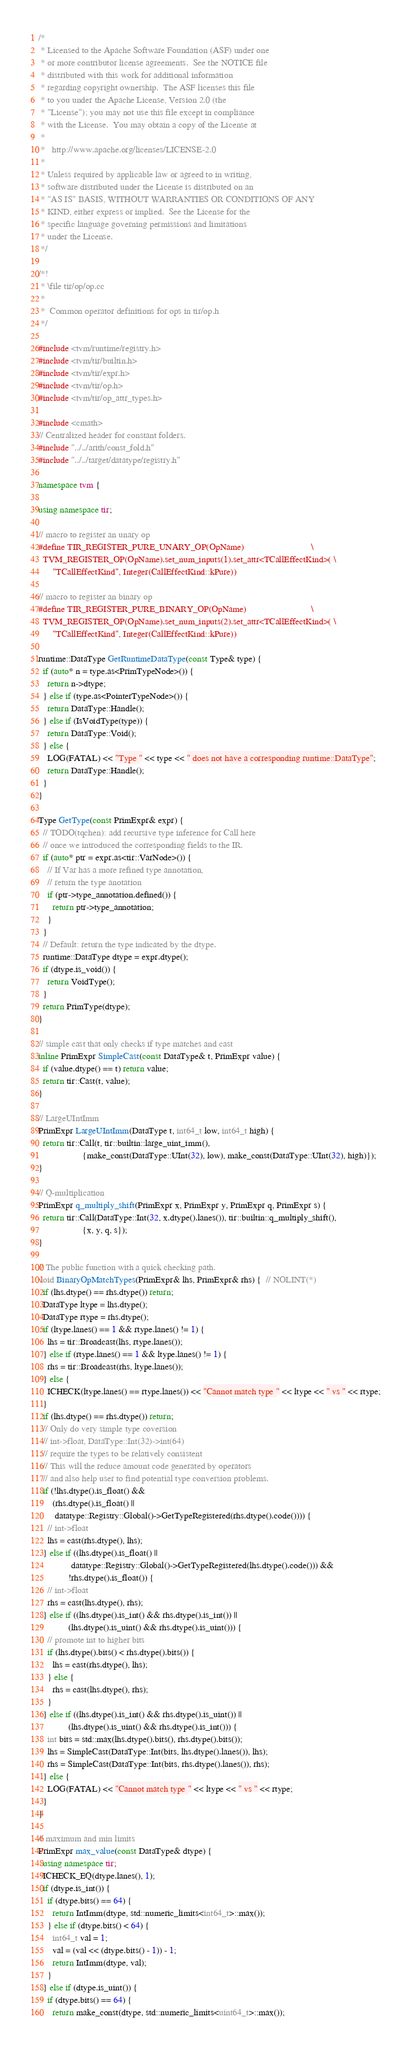Convert code to text. <code><loc_0><loc_0><loc_500><loc_500><_C++_>/*
 * Licensed to the Apache Software Foundation (ASF) under one
 * or more contributor license agreements.  See the NOTICE file
 * distributed with this work for additional information
 * regarding copyright ownership.  The ASF licenses this file
 * to you under the Apache License, Version 2.0 (the
 * "License"); you may not use this file except in compliance
 * with the License.  You may obtain a copy of the License at
 *
 *   http://www.apache.org/licenses/LICENSE-2.0
 *
 * Unless required by applicable law or agreed to in writing,
 * software distributed under the License is distributed on an
 * "AS IS" BASIS, WITHOUT WARRANTIES OR CONDITIONS OF ANY
 * KIND, either express or implied.  See the License for the
 * specific language governing permissions and limitations
 * under the License.
 */

/*!
 * \file tir/op/op.cc
 *
 *  Common operator definitions for ops in tir/op.h
 */

#include <tvm/runtime/registry.h>
#include <tvm/tir/builtin.h>
#include <tvm/tir/expr.h>
#include <tvm/tir/op.h>
#include <tvm/tir/op_attr_types.h>

#include <cmath>
// Centralized header for constant folders.
#include "../../arith/const_fold.h"
#include "../../target/datatype/registry.h"

namespace tvm {

using namespace tir;

// macro to register an unary op
#define TIR_REGISTER_PURE_UNARY_OP(OpName)                             \
  TVM_REGISTER_OP(OpName).set_num_inputs(1).set_attr<TCallEffectKind>( \
      "TCallEffectKind", Integer(CallEffectKind::kPure))

// macro to register an binary op
#define TIR_REGISTER_PURE_BINARY_OP(OpName)                            \
  TVM_REGISTER_OP(OpName).set_num_inputs(2).set_attr<TCallEffectKind>( \
      "TCallEffectKind", Integer(CallEffectKind::kPure))

runtime::DataType GetRuntimeDataType(const Type& type) {
  if (auto* n = type.as<PrimTypeNode>()) {
    return n->dtype;
  } else if (type.as<PointerTypeNode>()) {
    return DataType::Handle();
  } else if (IsVoidType(type)) {
    return DataType::Void();
  } else {
    LOG(FATAL) << "Type " << type << " does not have a corresponding runtime::DataType";
    return DataType::Handle();
  }
}

Type GetType(const PrimExpr& expr) {
  // TODO(tqchen): add recursive type inference for Call here
  // once we introduced the corresponding fields to the IR.
  if (auto* ptr = expr.as<tir::VarNode>()) {
    // If Var has a more refined type annotation,
    // return the type anotation
    if (ptr->type_annotation.defined()) {
      return ptr->type_annotation;
    }
  }
  // Default: return the type indicated by the dtype.
  runtime::DataType dtype = expr.dtype();
  if (dtype.is_void()) {
    return VoidType();
  }
  return PrimType(dtype);
}

// simple cast that only checks if type matches and cast
inline PrimExpr SimpleCast(const DataType& t, PrimExpr value) {
  if (value.dtype() == t) return value;
  return tir::Cast(t, value);
}

// LargeUIntImm
PrimExpr LargeUIntImm(DataType t, int64_t low, int64_t high) {
  return tir::Call(t, tir::builtin::large_uint_imm(),
                   {make_const(DataType::UInt(32), low), make_const(DataType::UInt(32), high)});
}

// Q-multiplication
PrimExpr q_multiply_shift(PrimExpr x, PrimExpr y, PrimExpr q, PrimExpr s) {
  return tir::Call(DataType::Int(32, x.dtype().lanes()), tir::builtin::q_multiply_shift(),
                   {x, y, q, s});
}

// The public function with a quick checking path.
void BinaryOpMatchTypes(PrimExpr& lhs, PrimExpr& rhs) {  // NOLINT(*)
  if (lhs.dtype() == rhs.dtype()) return;
  DataType ltype = lhs.dtype();
  DataType rtype = rhs.dtype();
  if (ltype.lanes() == 1 && rtype.lanes() != 1) {
    lhs = tir::Broadcast(lhs, rtype.lanes());
  } else if (rtype.lanes() == 1 && ltype.lanes() != 1) {
    rhs = tir::Broadcast(rhs, ltype.lanes());
  } else {
    ICHECK(ltype.lanes() == rtype.lanes()) << "Cannot match type " << ltype << " vs " << rtype;
  }
  if (lhs.dtype() == rhs.dtype()) return;
  // Only do very simple type coversion
  // int->float, DataType::Int(32)->int(64)
  // require the types to be relatively consistent
  // This will the reduce amount code generated by operators
  // and also help user to find potential type conversion problems.
  if (!lhs.dtype().is_float() &&
      (rhs.dtype().is_float() ||
       datatype::Registry::Global()->GetTypeRegistered(rhs.dtype().code()))) {
    // int->float
    lhs = cast(rhs.dtype(), lhs);
  } else if ((lhs.dtype().is_float() ||
              datatype::Registry::Global()->GetTypeRegistered(lhs.dtype().code())) &&
             !rhs.dtype().is_float()) {
    // int->float
    rhs = cast(lhs.dtype(), rhs);
  } else if ((lhs.dtype().is_int() && rhs.dtype().is_int()) ||
             (lhs.dtype().is_uint() && rhs.dtype().is_uint())) {
    // promote int to higher bits
    if (lhs.dtype().bits() < rhs.dtype().bits()) {
      lhs = cast(rhs.dtype(), lhs);
    } else {
      rhs = cast(lhs.dtype(), rhs);
    }
  } else if ((lhs.dtype().is_int() && rhs.dtype().is_uint()) ||
             (lhs.dtype().is_uint() && rhs.dtype().is_int())) {
    int bits = std::max(lhs.dtype().bits(), rhs.dtype().bits());
    lhs = SimpleCast(DataType::Int(bits, lhs.dtype().lanes()), lhs);
    rhs = SimpleCast(DataType::Int(bits, rhs.dtype().lanes()), rhs);
  } else {
    LOG(FATAL) << "Cannot match type " << ltype << " vs " << rtype;
  }
}

// maximum and min limits
PrimExpr max_value(const DataType& dtype) {
  using namespace tir;
  ICHECK_EQ(dtype.lanes(), 1);
  if (dtype.is_int()) {
    if (dtype.bits() == 64) {
      return IntImm(dtype, std::numeric_limits<int64_t>::max());
    } else if (dtype.bits() < 64) {
      int64_t val = 1;
      val = (val << (dtype.bits() - 1)) - 1;
      return IntImm(dtype, val);
    }
  } else if (dtype.is_uint()) {
    if (dtype.bits() == 64) {
      return make_const(dtype, std::numeric_limits<uint64_t>::max());</code> 